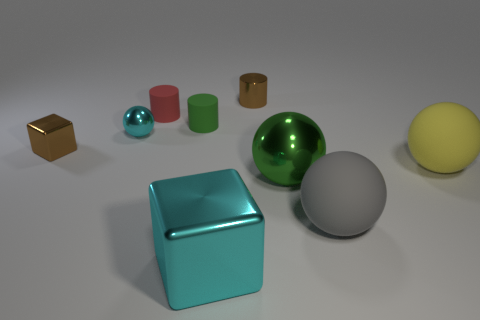Subtract all tiny brown metal cylinders. How many cylinders are left? 2 Add 1 blue cylinders. How many objects exist? 10 Subtract all green balls. How many balls are left? 3 Subtract all blue spheres. Subtract all red cylinders. How many spheres are left? 4 Subtract all tiny red cylinders. Subtract all green metal balls. How many objects are left? 7 Add 4 small brown metal things. How many small brown metal things are left? 6 Add 1 green spheres. How many green spheres exist? 2 Subtract 1 yellow spheres. How many objects are left? 8 Subtract all cylinders. How many objects are left? 6 